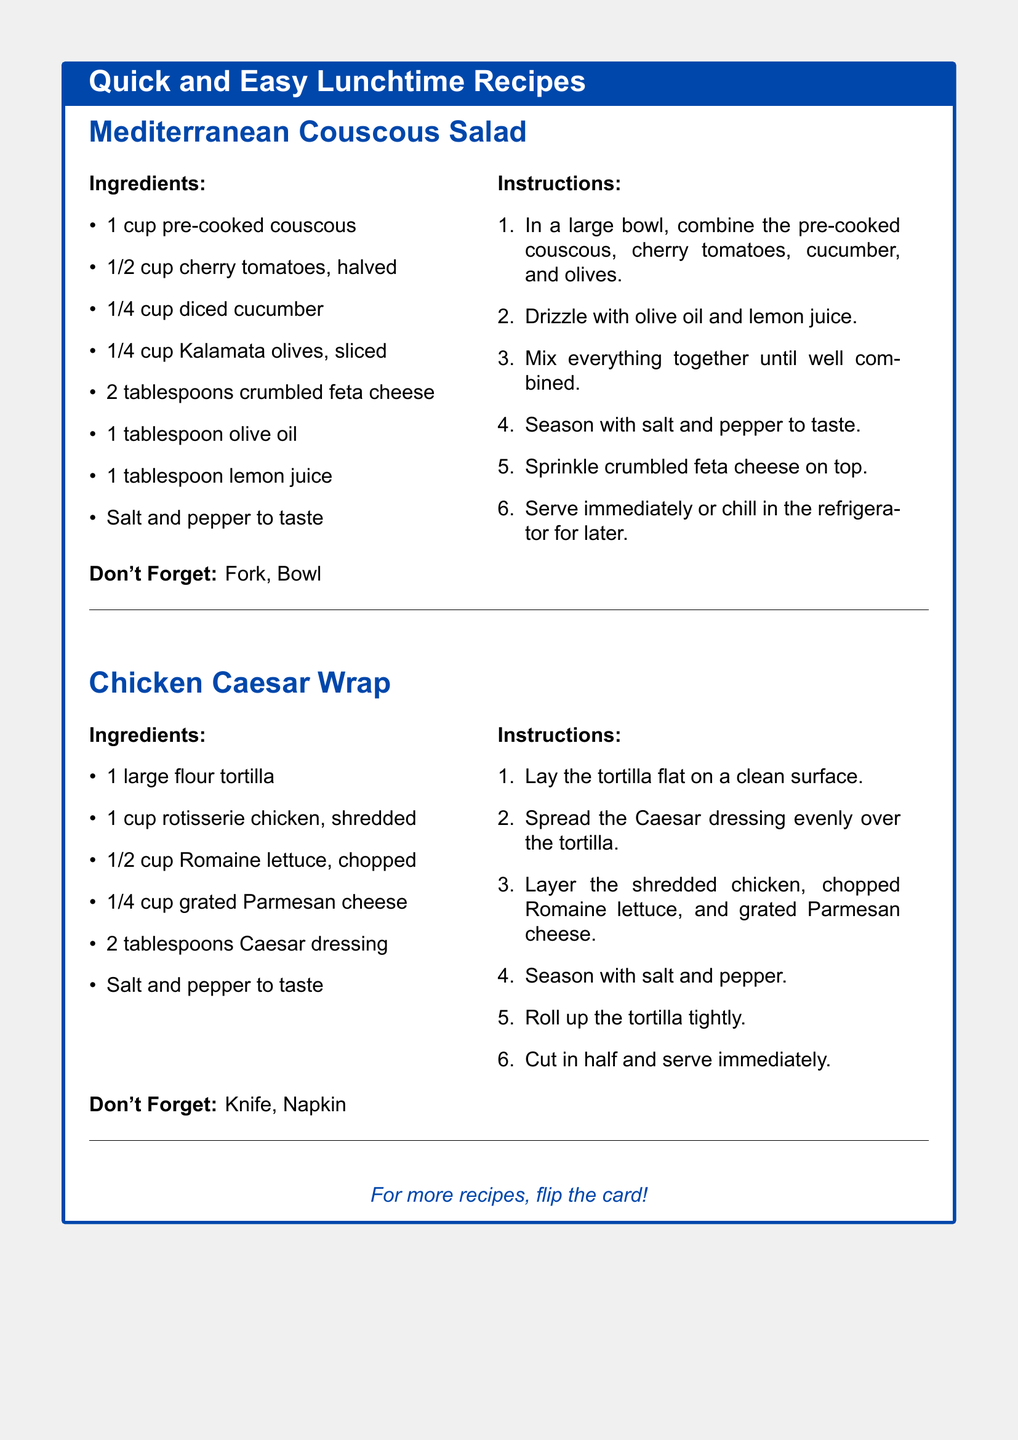What is the first recipe mentioned? The first recipe listed in the document is Mediterranean Couscous Salad.
Answer: Mediterranean Couscous Salad How many cherry tomatoes are needed? The recipe for Mediterranean Couscous Salad requires half a cup of cherry tomatoes.
Answer: 1/2 cup What is the main protein in the Chicken Caesar Wrap? The Chicken Caesar Wrap features rotisserie chicken as its main protein.
Answer: Rotisserie chicken How many steps are in the Chicken Caesar Wrap instructions? The instructions for Chicken Caesar Wrap consist of six steps.
Answer: 6 What cheese is used in the Mediterranean Couscous Salad? The cheese used in the Mediterranean Couscous Salad is crumbled feta cheese.
Answer: Feta cheese What should you not forget when preparing the Mediterranean Couscous Salad? The document advises not to forget a fork and bowl for the Mediterranean Couscous Salad.
Answer: Fork, Bowl How much Caesar dressing is needed for the wrap? The Chicken Caesar Wrap requires two tablespoons of Caesar dressing.
Answer: 2 tablespoons What type of tortilla is used in the Chicken Caesar Wrap? The Chicken Caesar Wrap is made using a large flour tortilla.
Answer: Flour tortilla 